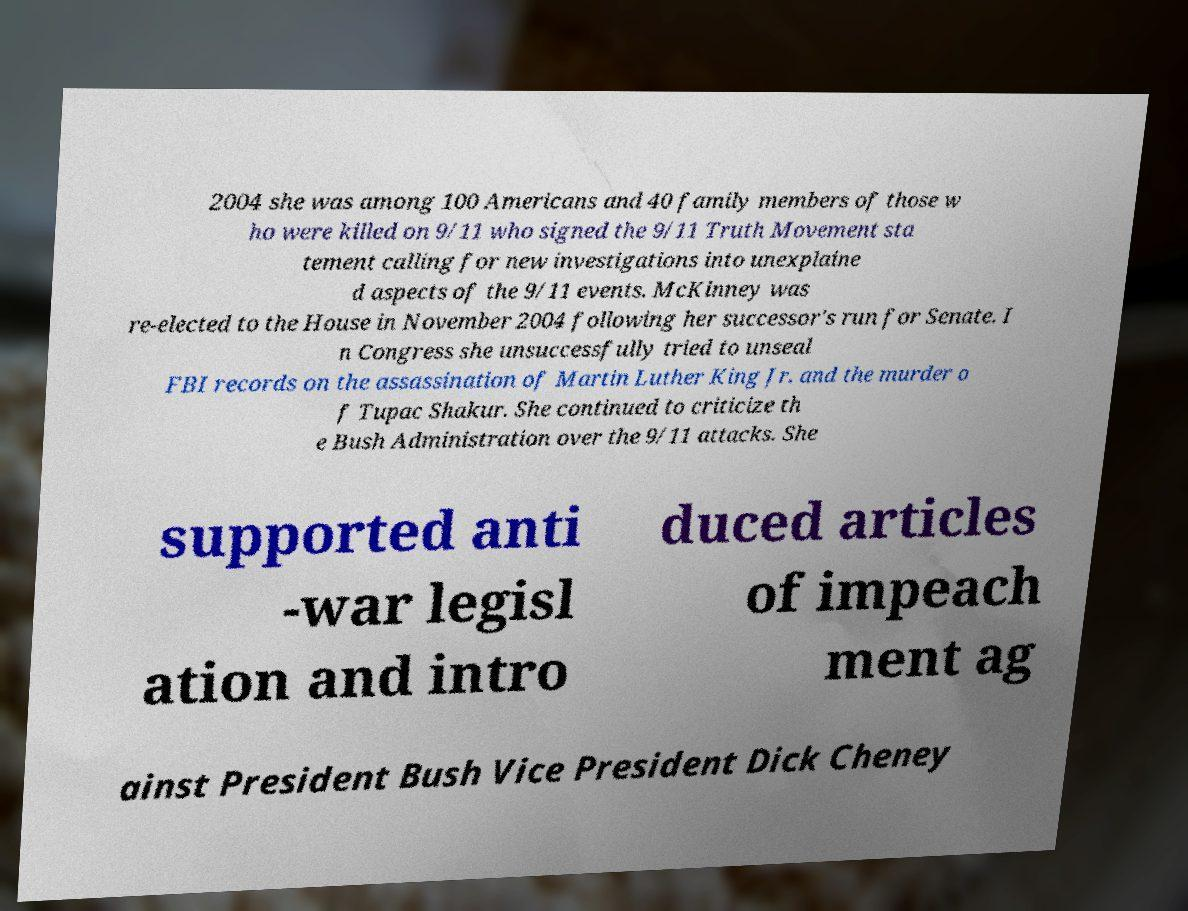Can you accurately transcribe the text from the provided image for me? 2004 she was among 100 Americans and 40 family members of those w ho were killed on 9/11 who signed the 9/11 Truth Movement sta tement calling for new investigations into unexplaine d aspects of the 9/11 events. McKinney was re-elected to the House in November 2004 following her successor's run for Senate. I n Congress she unsuccessfully tried to unseal FBI records on the assassination of Martin Luther King Jr. and the murder o f Tupac Shakur. She continued to criticize th e Bush Administration over the 9/11 attacks. She supported anti -war legisl ation and intro duced articles of impeach ment ag ainst President Bush Vice President Dick Cheney 